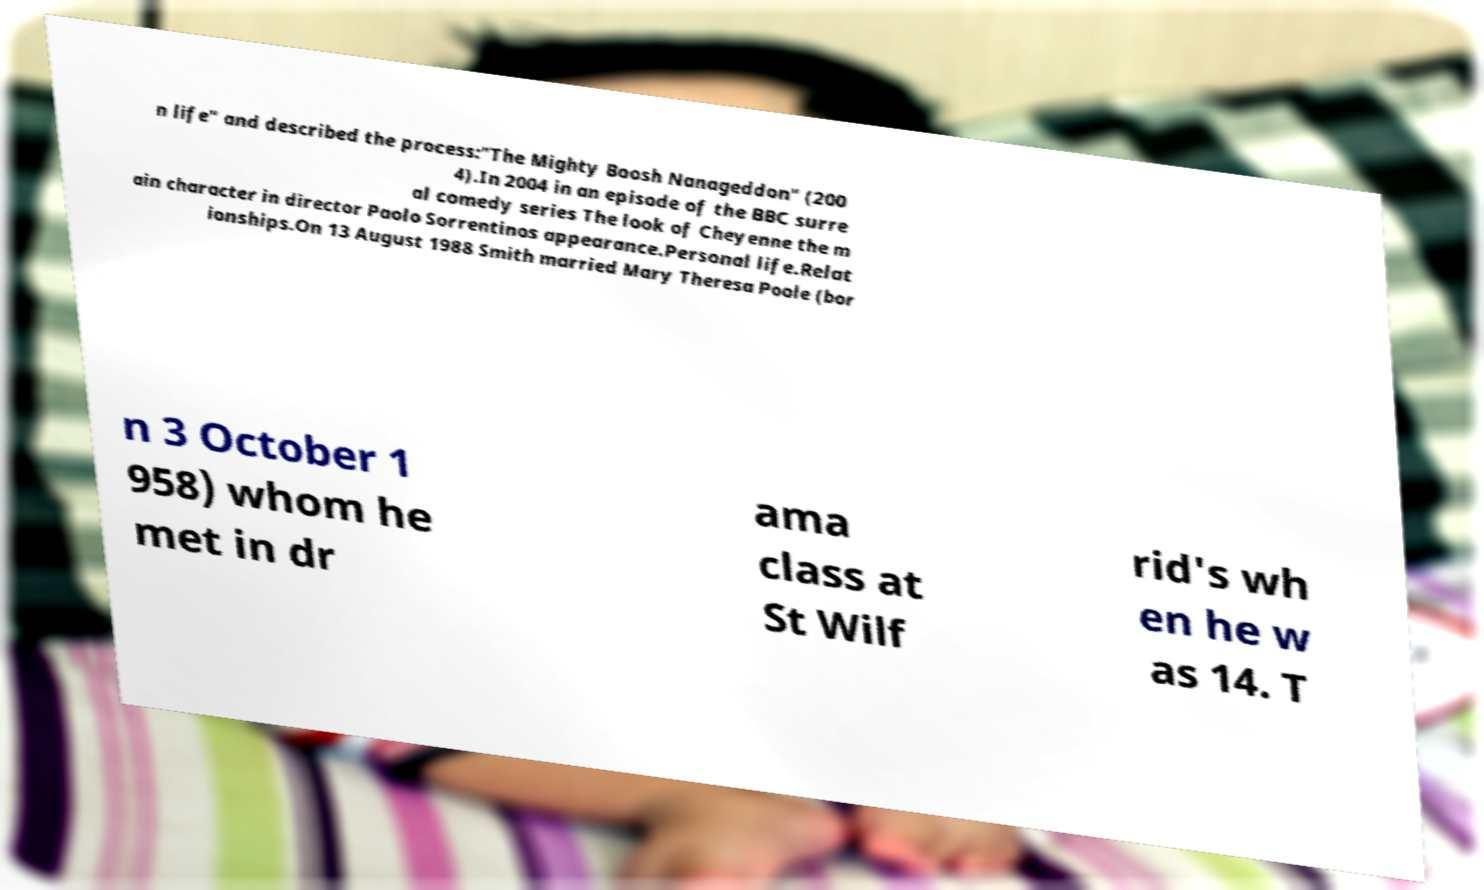Please read and relay the text visible in this image. What does it say? n life" and described the process:"The Mighty Boosh Nanageddon" (200 4).In 2004 in an episode of the BBC surre al comedy series The look of Cheyenne the m ain character in director Paolo Sorrentinos appearance.Personal life.Relat ionships.On 13 August 1988 Smith married Mary Theresa Poole (bor n 3 October 1 958) whom he met in dr ama class at St Wilf rid's wh en he w as 14. T 